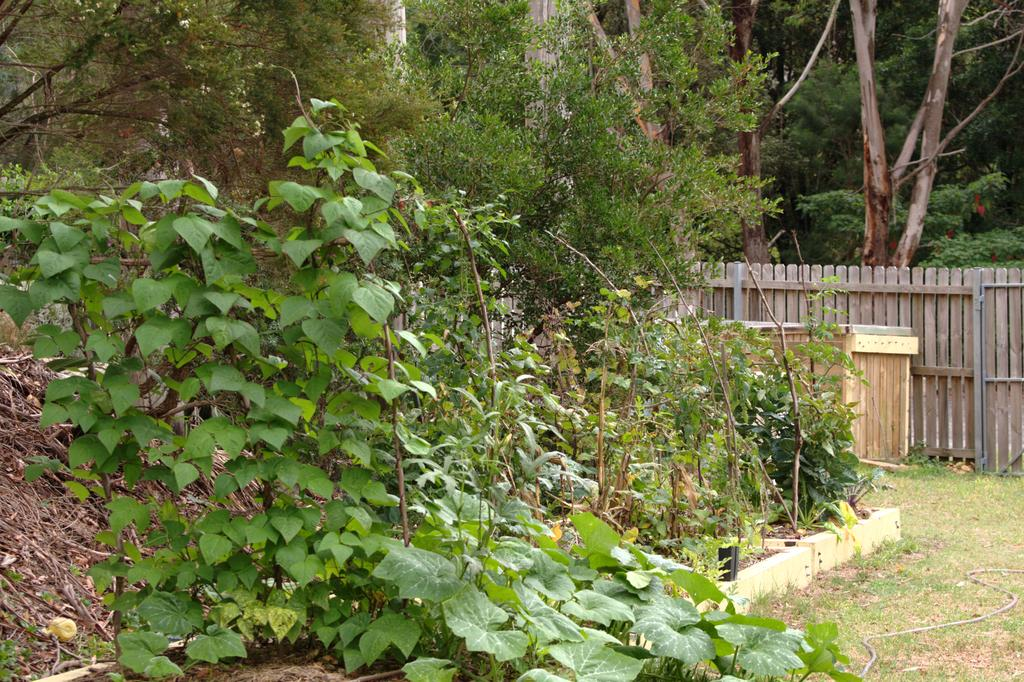What type of living organisms can be seen in the image? Plants and trees can be seen in the image. What type of fence is on the right side of the image? There is a wooden fence on the right side of the image. What type of vegetation is visible in the image? Trees are visible in the image. What type of bushes can be seen growing in the shape of a reward in the image? There are no bushes or rewards present in the image; it features plants and trees. 